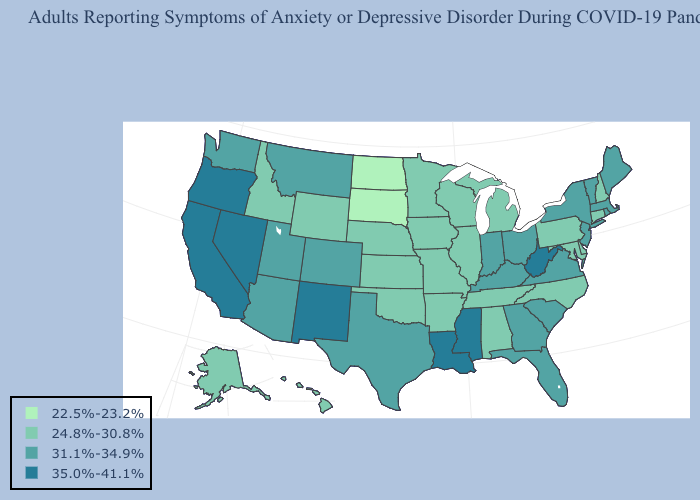How many symbols are there in the legend?
Answer briefly. 4. Name the states that have a value in the range 22.5%-23.2%?
Keep it brief. North Dakota, South Dakota. Name the states that have a value in the range 22.5%-23.2%?
Keep it brief. North Dakota, South Dakota. Does the first symbol in the legend represent the smallest category?
Give a very brief answer. Yes. What is the value of West Virginia?
Be succinct. 35.0%-41.1%. Name the states that have a value in the range 24.8%-30.8%?
Give a very brief answer. Alabama, Alaska, Arkansas, Connecticut, Delaware, Hawaii, Idaho, Illinois, Iowa, Kansas, Maryland, Michigan, Minnesota, Missouri, Nebraska, New Hampshire, North Carolina, Oklahoma, Pennsylvania, Tennessee, Wisconsin, Wyoming. What is the value of Mississippi?
Keep it brief. 35.0%-41.1%. Name the states that have a value in the range 24.8%-30.8%?
Short answer required. Alabama, Alaska, Arkansas, Connecticut, Delaware, Hawaii, Idaho, Illinois, Iowa, Kansas, Maryland, Michigan, Minnesota, Missouri, Nebraska, New Hampshire, North Carolina, Oklahoma, Pennsylvania, Tennessee, Wisconsin, Wyoming. What is the lowest value in the USA?
Give a very brief answer. 22.5%-23.2%. Name the states that have a value in the range 35.0%-41.1%?
Short answer required. California, Louisiana, Mississippi, Nevada, New Mexico, Oregon, West Virginia. Name the states that have a value in the range 35.0%-41.1%?
Answer briefly. California, Louisiana, Mississippi, Nevada, New Mexico, Oregon, West Virginia. What is the value of Massachusetts?
Be succinct. 31.1%-34.9%. Does the first symbol in the legend represent the smallest category?
Concise answer only. Yes. Does Arizona have the lowest value in the West?
Quick response, please. No. 